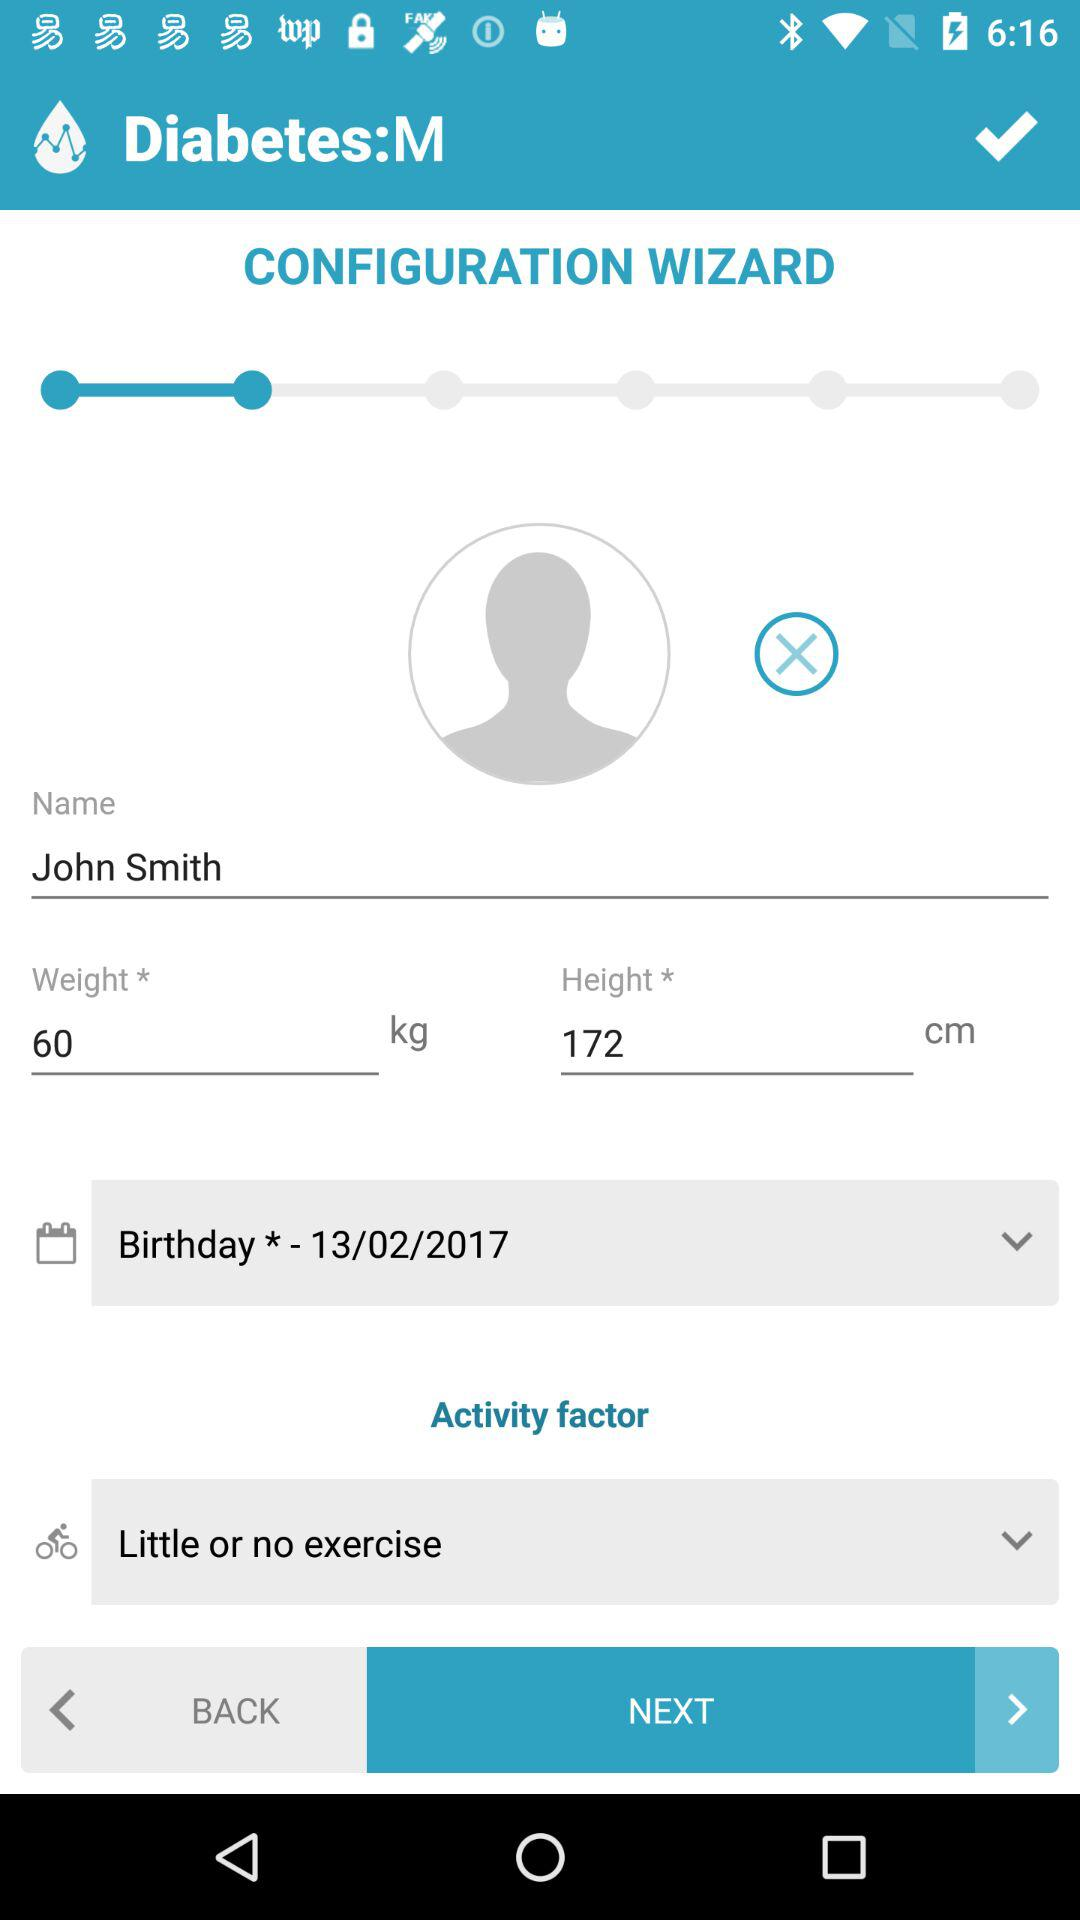What is the height? The height is 172 cm. 